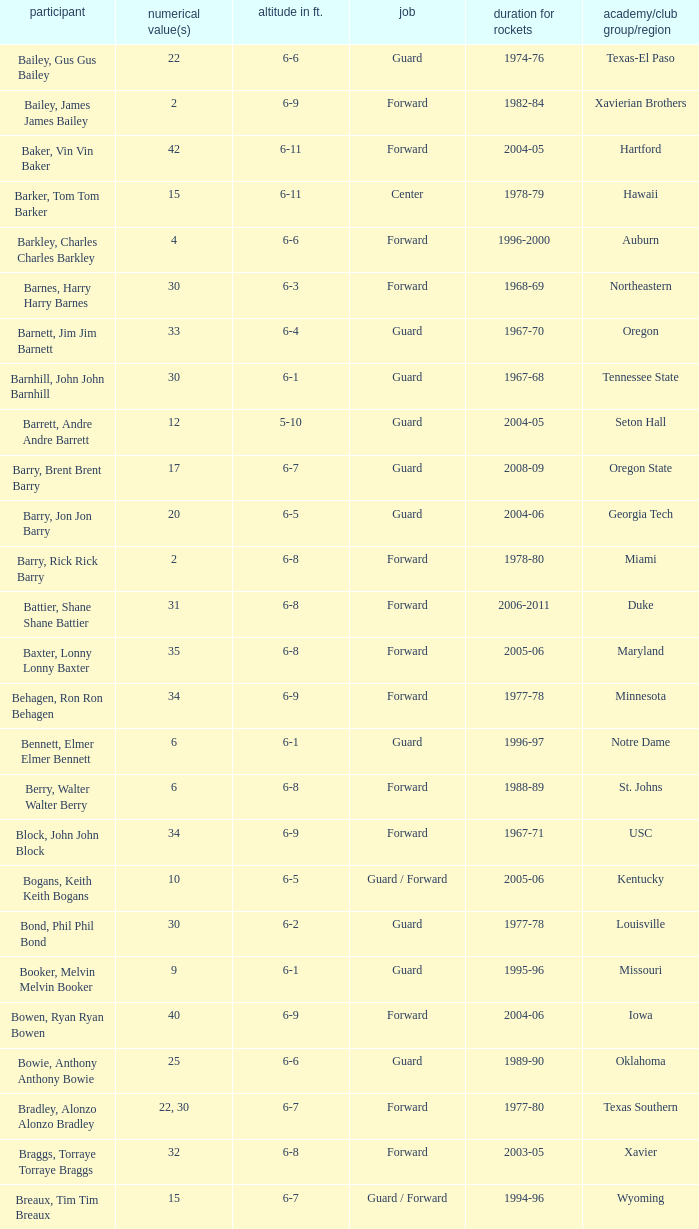What years did the player from LaSalle play for the Rockets? 1982-83. 